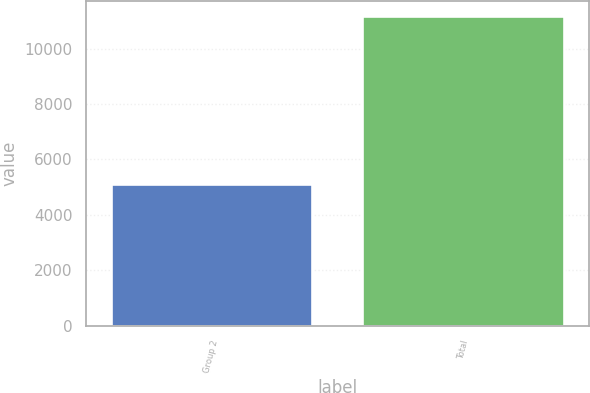<chart> <loc_0><loc_0><loc_500><loc_500><bar_chart><fcel>Group 2<fcel>Total<nl><fcel>5107.3<fcel>11163.2<nl></chart> 